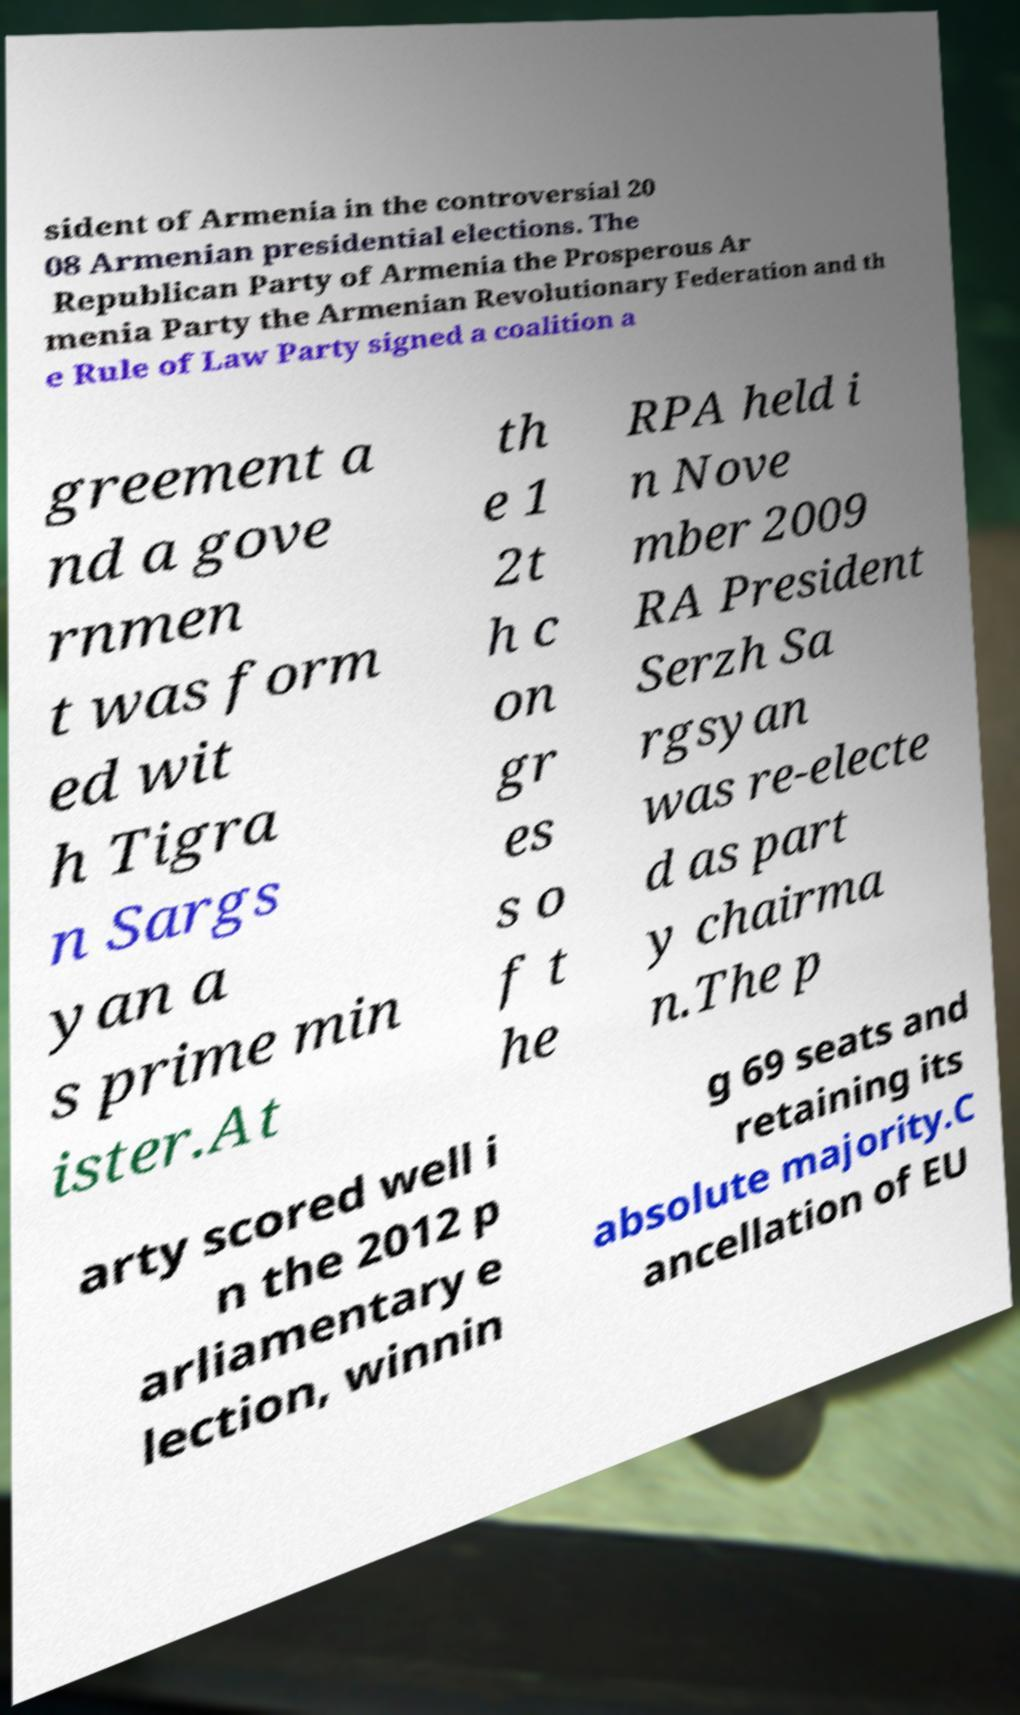Please identify and transcribe the text found in this image. sident of Armenia in the controversial 20 08 Armenian presidential elections. The Republican Party of Armenia the Prosperous Ar menia Party the Armenian Revolutionary Federation and th e Rule of Law Party signed a coalition a greement a nd a gove rnmen t was form ed wit h Tigra n Sargs yan a s prime min ister.At th e 1 2t h c on gr es s o f t he RPA held i n Nove mber 2009 RA President Serzh Sa rgsyan was re-electe d as part y chairma n.The p arty scored well i n the 2012 p arliamentary e lection, winnin g 69 seats and retaining its absolute majority.C ancellation of EU 